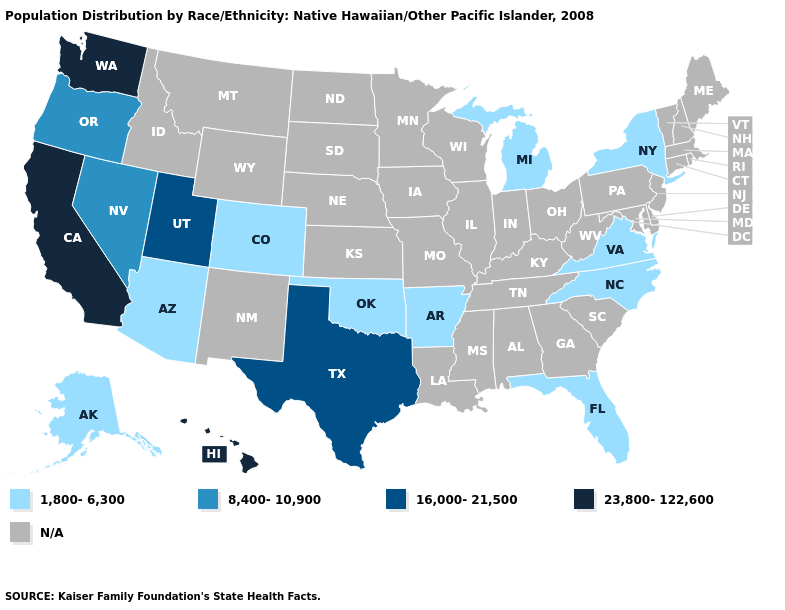What is the highest value in states that border New Jersey?
Keep it brief. 1,800-6,300. Name the states that have a value in the range 16,000-21,500?
Answer briefly. Texas, Utah. Name the states that have a value in the range N/A?
Keep it brief. Alabama, Connecticut, Delaware, Georgia, Idaho, Illinois, Indiana, Iowa, Kansas, Kentucky, Louisiana, Maine, Maryland, Massachusetts, Minnesota, Mississippi, Missouri, Montana, Nebraska, New Hampshire, New Jersey, New Mexico, North Dakota, Ohio, Pennsylvania, Rhode Island, South Carolina, South Dakota, Tennessee, Vermont, West Virginia, Wisconsin, Wyoming. What is the value of Arizona?
Quick response, please. 1,800-6,300. What is the value of Georgia?
Keep it brief. N/A. Does Hawaii have the highest value in the USA?
Answer briefly. Yes. What is the value of Pennsylvania?
Short answer required. N/A. What is the lowest value in the South?
Short answer required. 1,800-6,300. Name the states that have a value in the range 1,800-6,300?
Write a very short answer. Alaska, Arizona, Arkansas, Colorado, Florida, Michigan, New York, North Carolina, Oklahoma, Virginia. Name the states that have a value in the range 16,000-21,500?
Keep it brief. Texas, Utah. Name the states that have a value in the range 8,400-10,900?
Give a very brief answer. Nevada, Oregon. What is the value of Maine?
Quick response, please. N/A. 